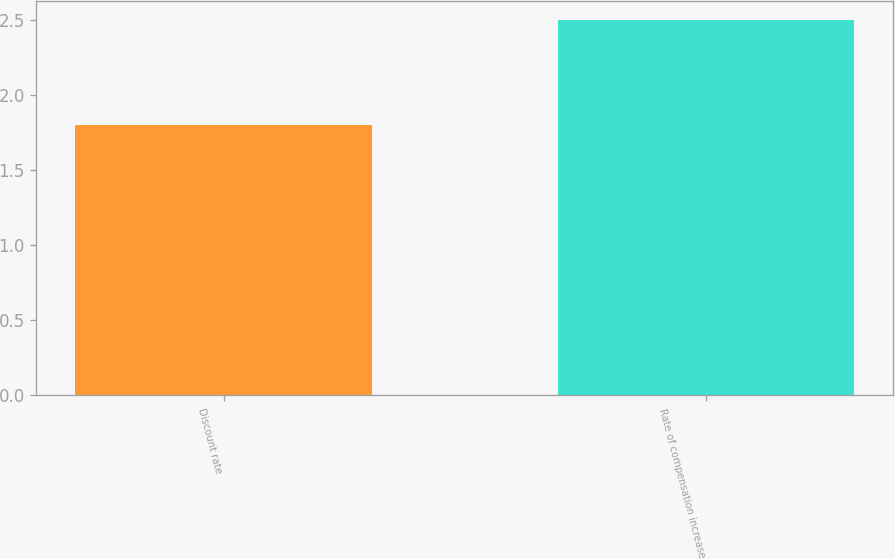<chart> <loc_0><loc_0><loc_500><loc_500><bar_chart><fcel>Discount rate<fcel>Rate of compensation increase<nl><fcel>1.8<fcel>2.5<nl></chart> 